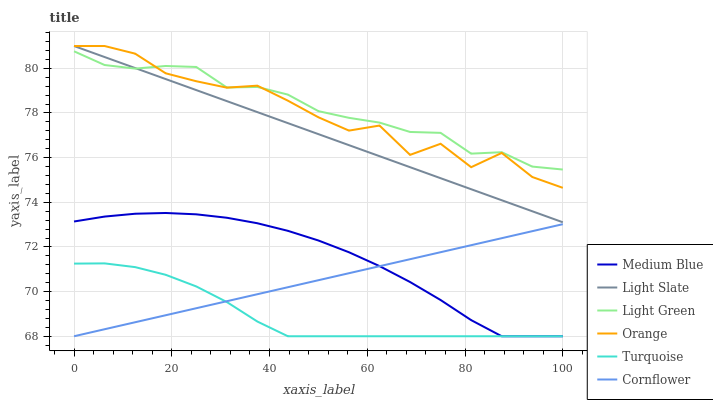Does Turquoise have the minimum area under the curve?
Answer yes or no. Yes. Does Light Green have the maximum area under the curve?
Answer yes or no. Yes. Does Light Slate have the minimum area under the curve?
Answer yes or no. No. Does Light Slate have the maximum area under the curve?
Answer yes or no. No. Is Light Slate the smoothest?
Answer yes or no. Yes. Is Orange the roughest?
Answer yes or no. Yes. Is Turquoise the smoothest?
Answer yes or no. No. Is Turquoise the roughest?
Answer yes or no. No. Does Cornflower have the lowest value?
Answer yes or no. Yes. Does Light Slate have the lowest value?
Answer yes or no. No. Does Orange have the highest value?
Answer yes or no. Yes. Does Turquoise have the highest value?
Answer yes or no. No. Is Turquoise less than Light Green?
Answer yes or no. Yes. Is Light Slate greater than Medium Blue?
Answer yes or no. Yes. Does Light Green intersect Light Slate?
Answer yes or no. Yes. Is Light Green less than Light Slate?
Answer yes or no. No. Is Light Green greater than Light Slate?
Answer yes or no. No. Does Turquoise intersect Light Green?
Answer yes or no. No. 